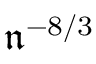Convert formula to latex. <formula><loc_0><loc_0><loc_500><loc_500>\mathfrak { n } ^ { - 8 / 3 }</formula> 